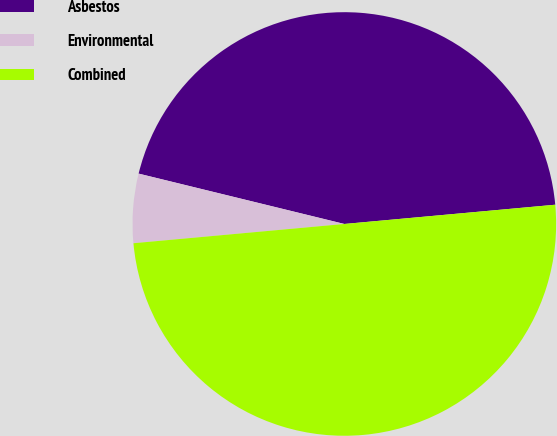Convert chart. <chart><loc_0><loc_0><loc_500><loc_500><pie_chart><fcel>Asbestos<fcel>Environmental<fcel>Combined<nl><fcel>44.73%<fcel>5.27%<fcel>50.0%<nl></chart> 